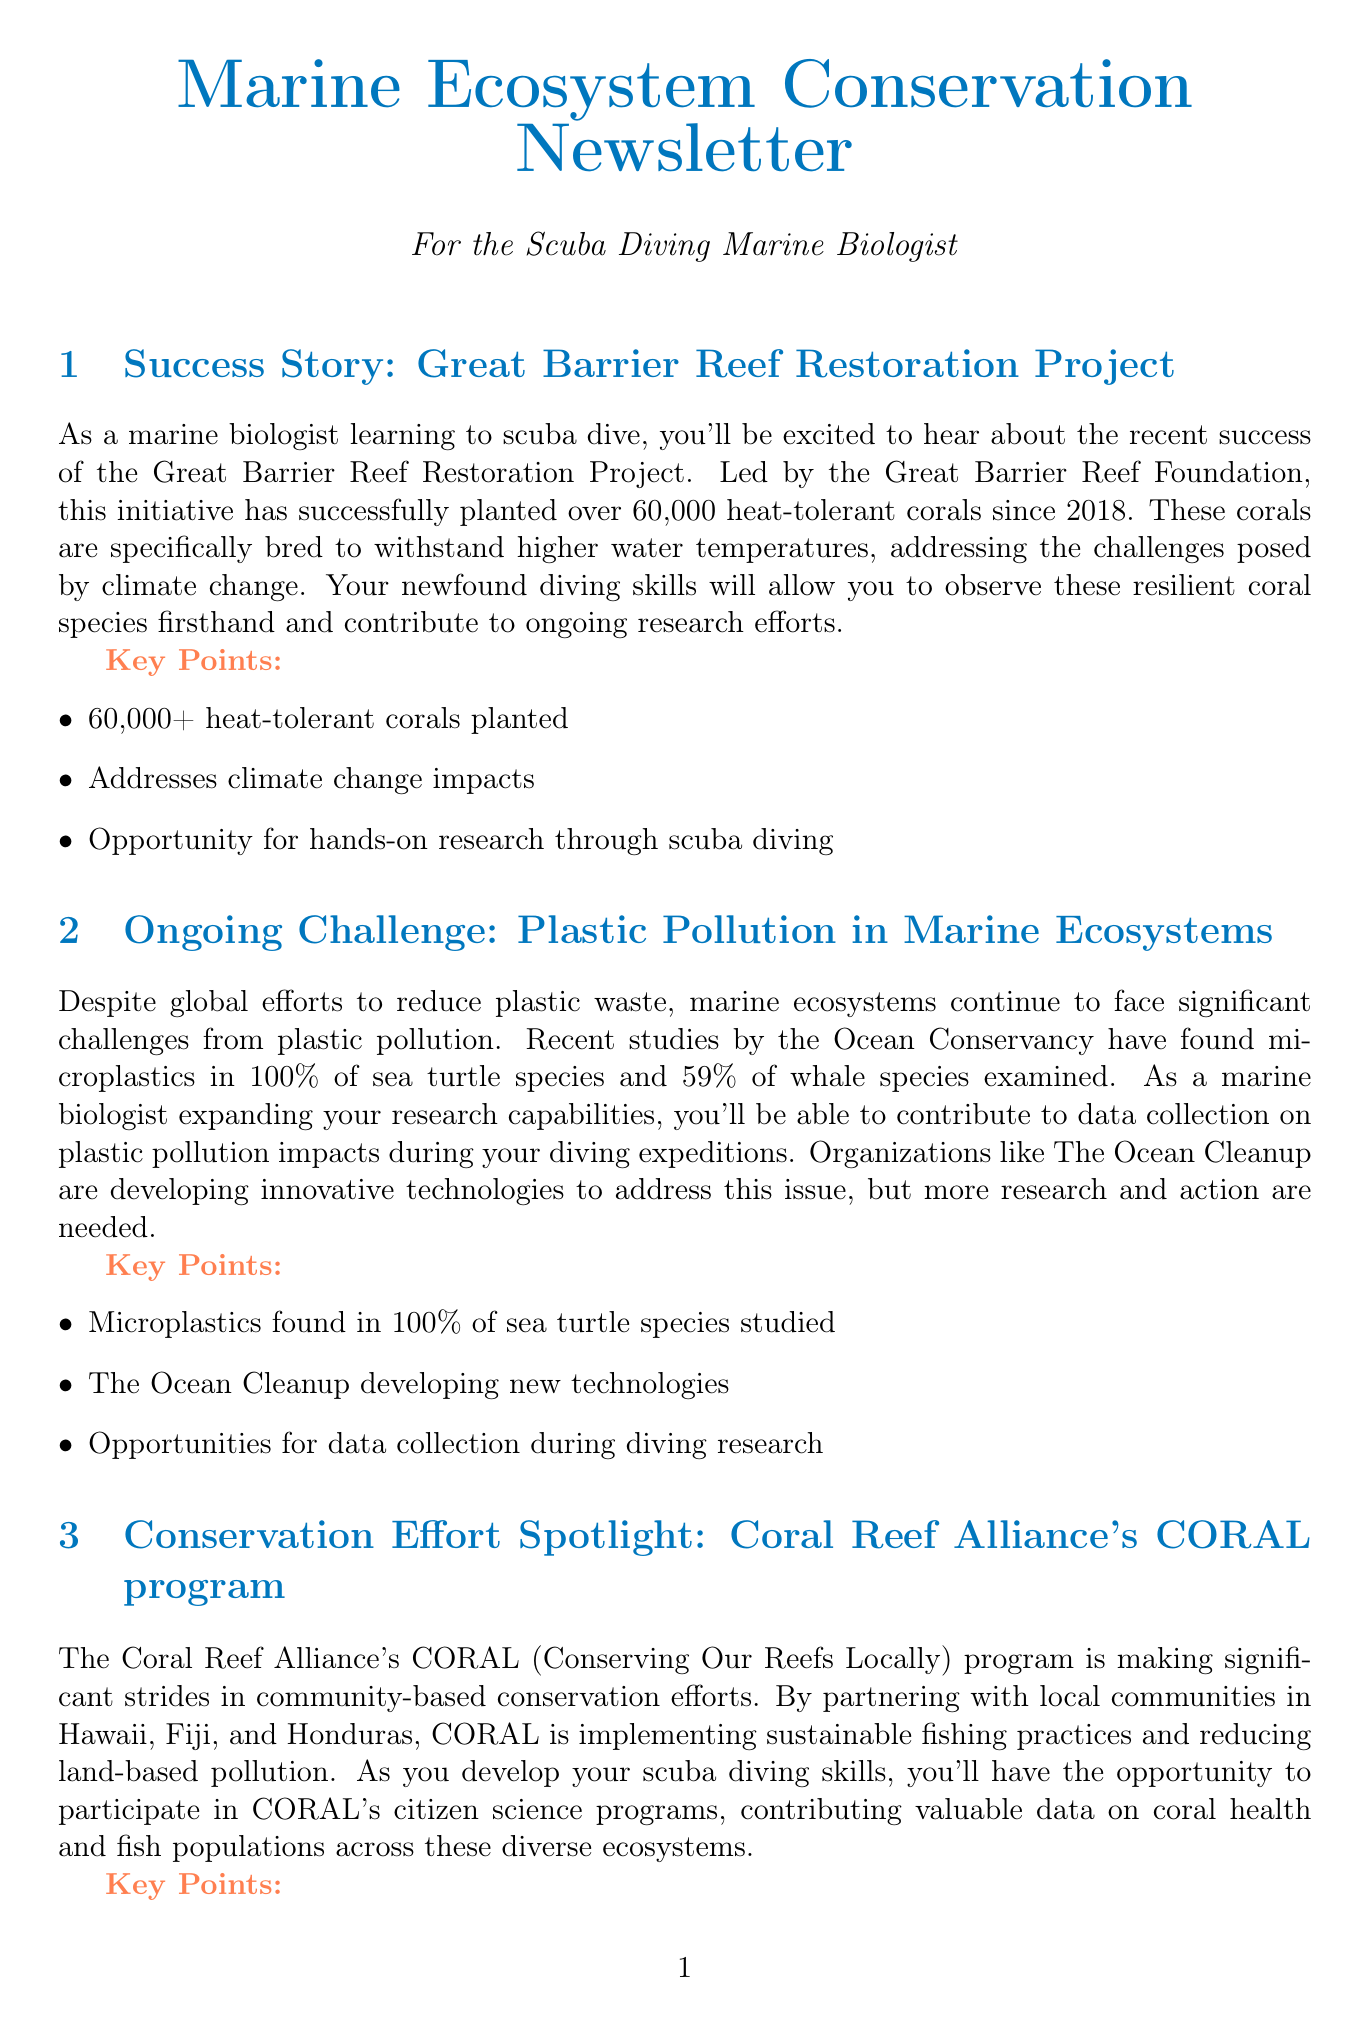What project has planted over 60,000 corals? The document mentions the Great Barrier Reef Restoration Project, which has successfully planted over 60,000 heat-tolerant corals since 2018.
Answer: Great Barrier Reef Restoration Project What percentage of sea turtle species have microplastics found? The document states that microplastics were found in 100% of the sea turtle species studied by the Ocean Conservancy.
Answer: 100% Which organization is developing technologies to address plastic pollution? The document identifies The Ocean Cleanup as the organization working on developing innovative technologies to tackle plastic pollution.
Answer: The Ocean Cleanup What does the CORAL program focus on? According to the document, the CORAL program focuses on community-based conservation efforts, specifically implementing sustainable fishing practices and reducing land-based pollution.
Answer: Sustainable fishing practices and pollution reduction What method is being used for biodiversity assessment in California's Marine Protected Areas? The document indicates that Environmental DNA (eDNA) sampling is the method currently being used for biodiversity assessments.
Answer: eDNA sampling How has the Schmidt Ocean Institute contributed to deep-sea ecosystem research? The document notes that the Schmidt Ocean Institute's expeditions have revealed unexpected resilience in deep-sea ecosystems, documenting thriving communities in areas affected by past mining.
Answer: Documenting thriving communities What locations is the Coral Reef Alliance partnering with? The document specifies that the Coral Reef Alliance is partnering with local communities in Hawaii, Fiji, and Honduras.
Answer: Hawaii, Fiji, and Honduras What opportunity does scuba diving offer in marine research according to the document? The document highlights that scuba diving provides opportunities for hands-on research and data collection on coral health, fish populations, and plastic pollution impacts.
Answer: Hands-on research and data collection 